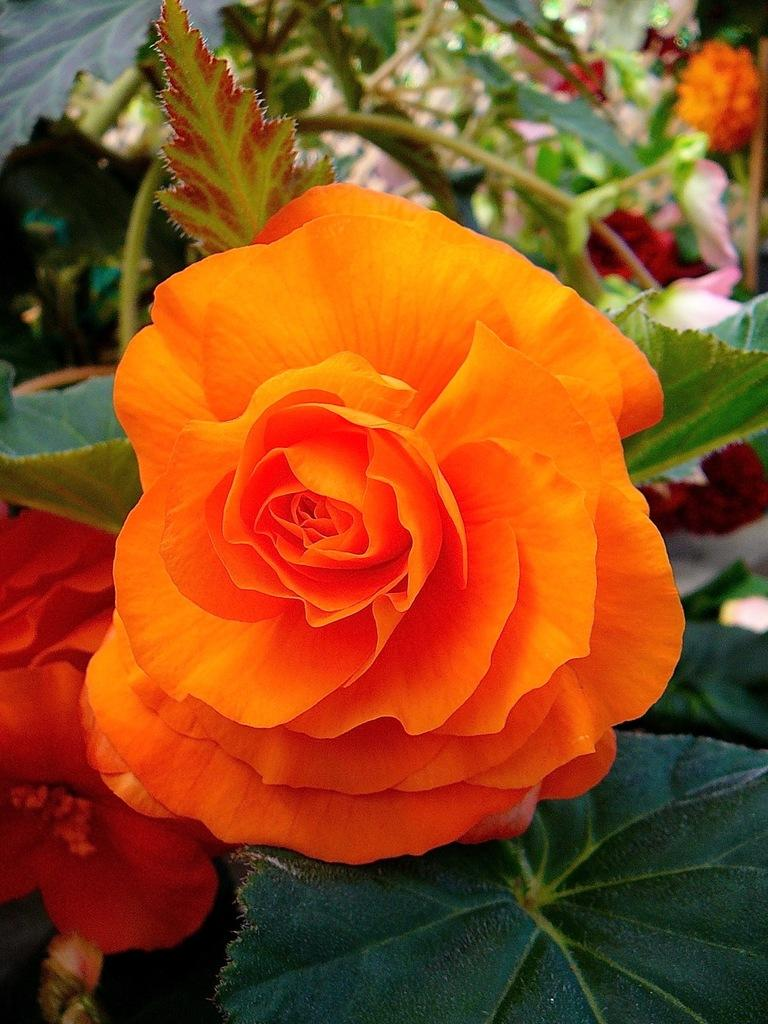What type of plant can be seen in the image? There is a flower with leaves in the image. Can you describe the background of the image? There are flowers on plants in the background of the image. What type of coal is being used in the oven in the image? There is no oven or coal present in the image; it features a flower with leaves and flowers on plants in the background. 